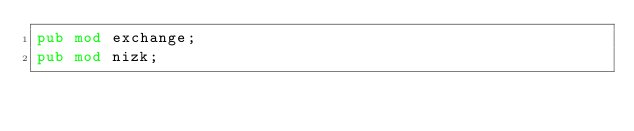<code> <loc_0><loc_0><loc_500><loc_500><_Rust_>pub mod exchange;
pub mod nizk;
</code> 